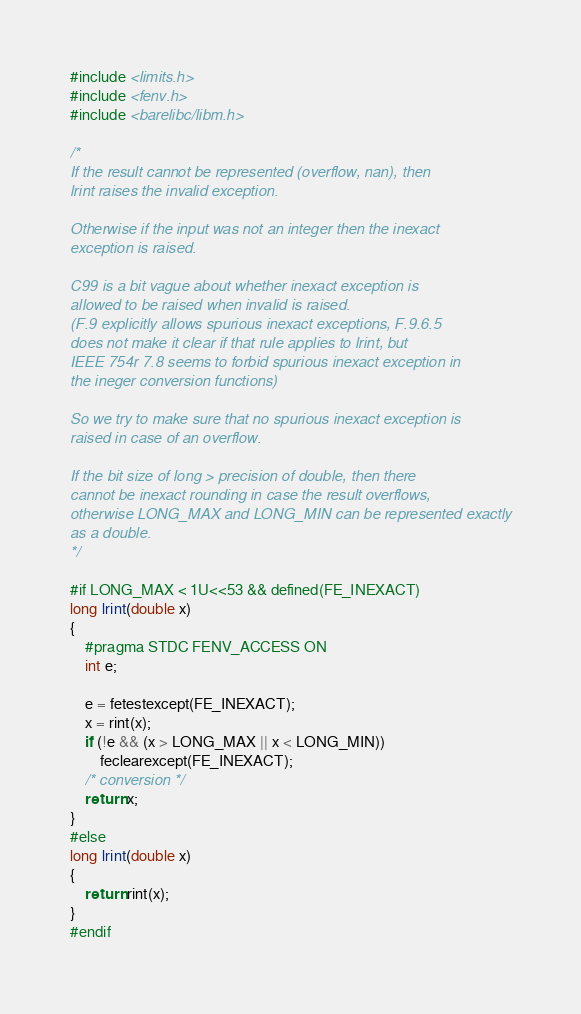Convert code to text. <code><loc_0><loc_0><loc_500><loc_500><_C_>#include <limits.h>
#include <fenv.h>
#include <barelibc/libm.h>

/*
If the result cannot be represented (overflow, nan), then
lrint raises the invalid exception.

Otherwise if the input was not an integer then the inexact
exception is raised.

C99 is a bit vague about whether inexact exception is
allowed to be raised when invalid is raised.
(F.9 explicitly allows spurious inexact exceptions, F.9.6.5
does not make it clear if that rule applies to lrint, but
IEEE 754r 7.8 seems to forbid spurious inexact exception in
the ineger conversion functions)

So we try to make sure that no spurious inexact exception is
raised in case of an overflow.

If the bit size of long > precision of double, then there
cannot be inexact rounding in case the result overflows,
otherwise LONG_MAX and LONG_MIN can be represented exactly
as a double.
*/

#if LONG_MAX < 1U<<53 && defined(FE_INEXACT)
long lrint(double x)
{
	#pragma STDC FENV_ACCESS ON
	int e;

	e = fetestexcept(FE_INEXACT);
	x = rint(x);
	if (!e && (x > LONG_MAX || x < LONG_MIN))
		feclearexcept(FE_INEXACT);
	/* conversion */
	return x;
}
#else
long lrint(double x)
{
	return rint(x);
}
#endif
</code> 